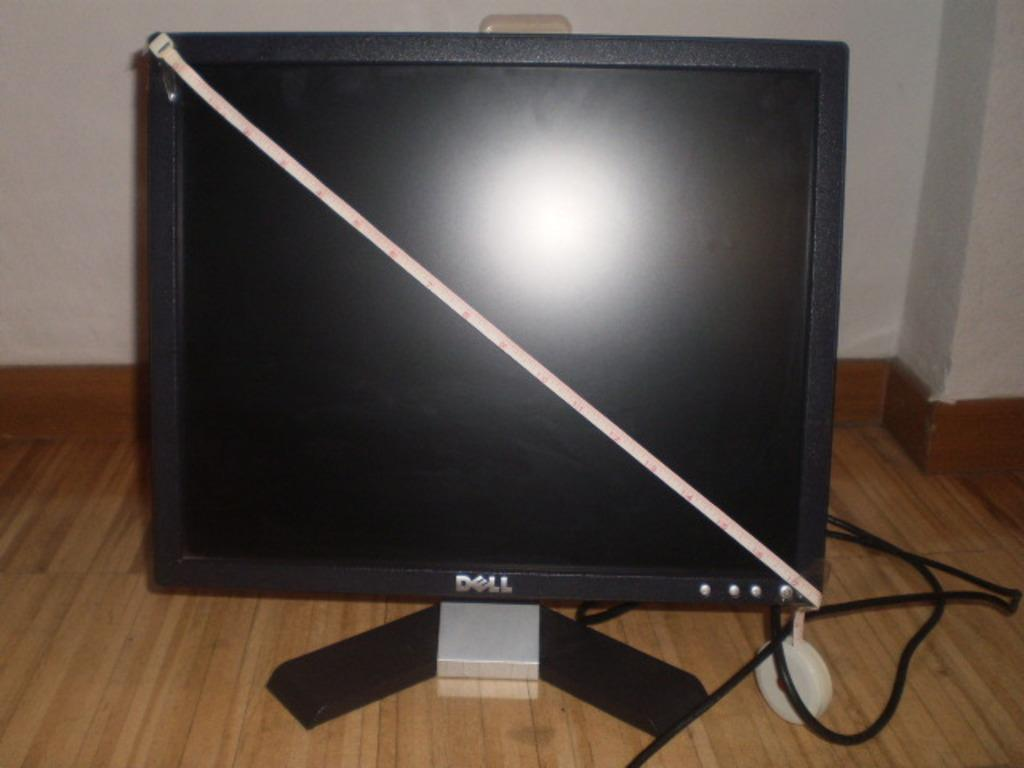<image>
Give a short and clear explanation of the subsequent image. A Dell computer monitor with a diagonal measuring tape on it. 